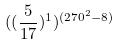Convert formula to latex. <formula><loc_0><loc_0><loc_500><loc_500>( ( \frac { 5 } { 1 7 } ) ^ { 1 } ) ^ { ( 2 7 0 ^ { 2 } - 8 ) }</formula> 